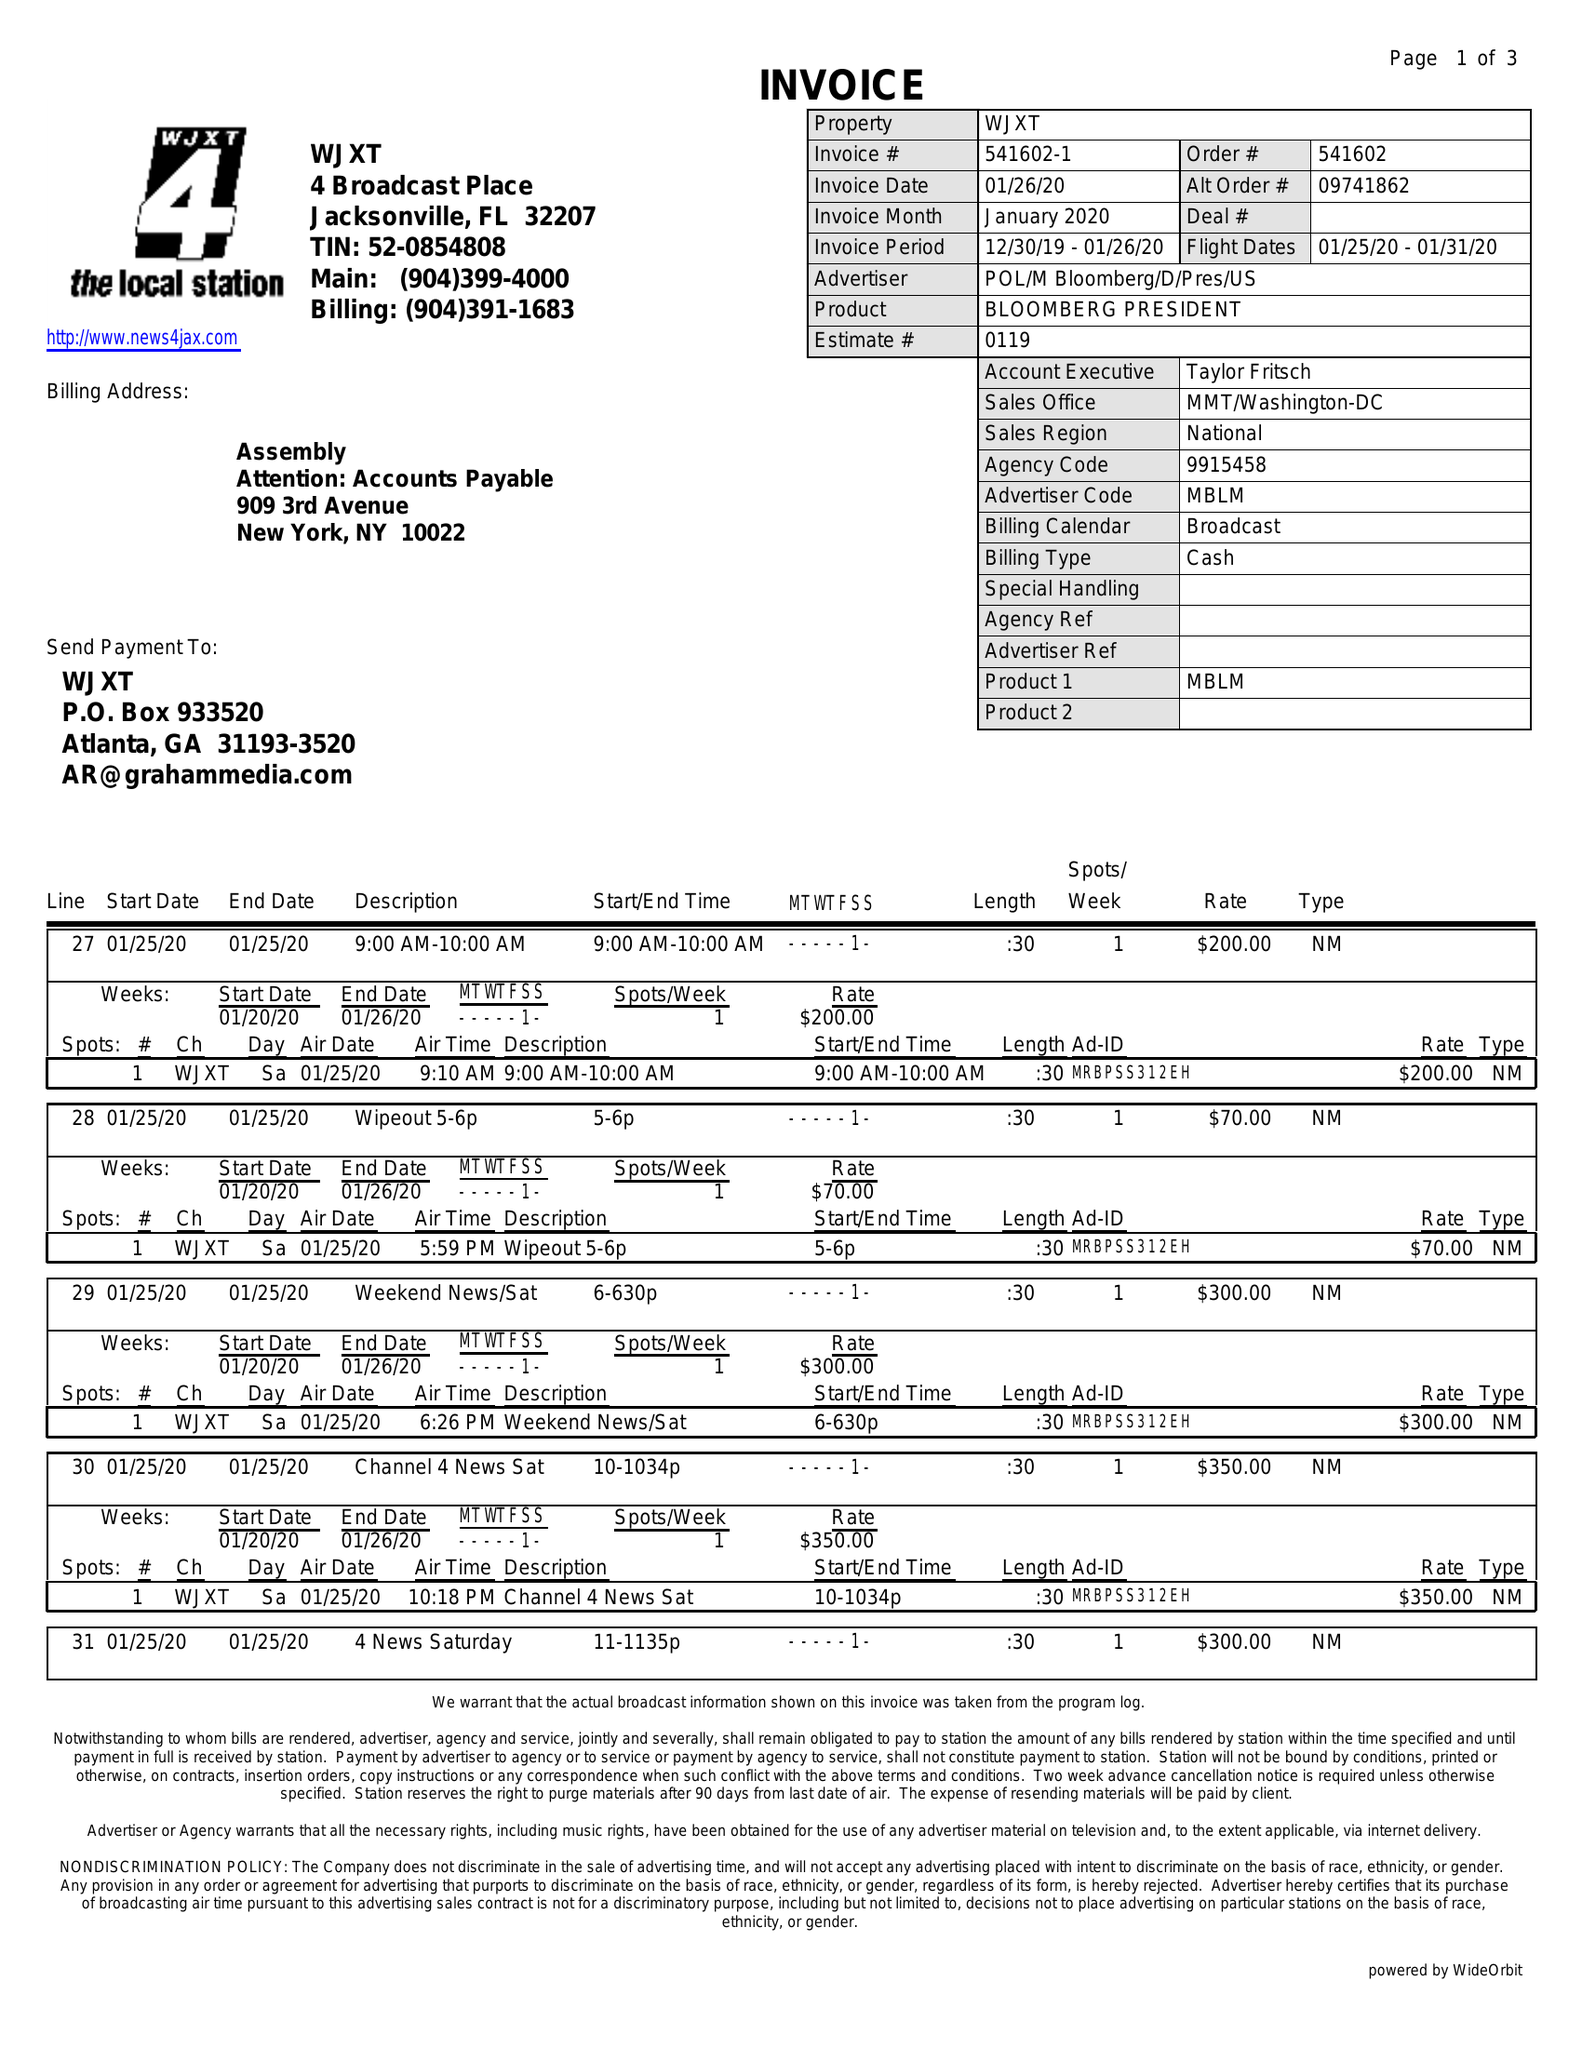What is the value for the contract_num?
Answer the question using a single word or phrase. 541602 